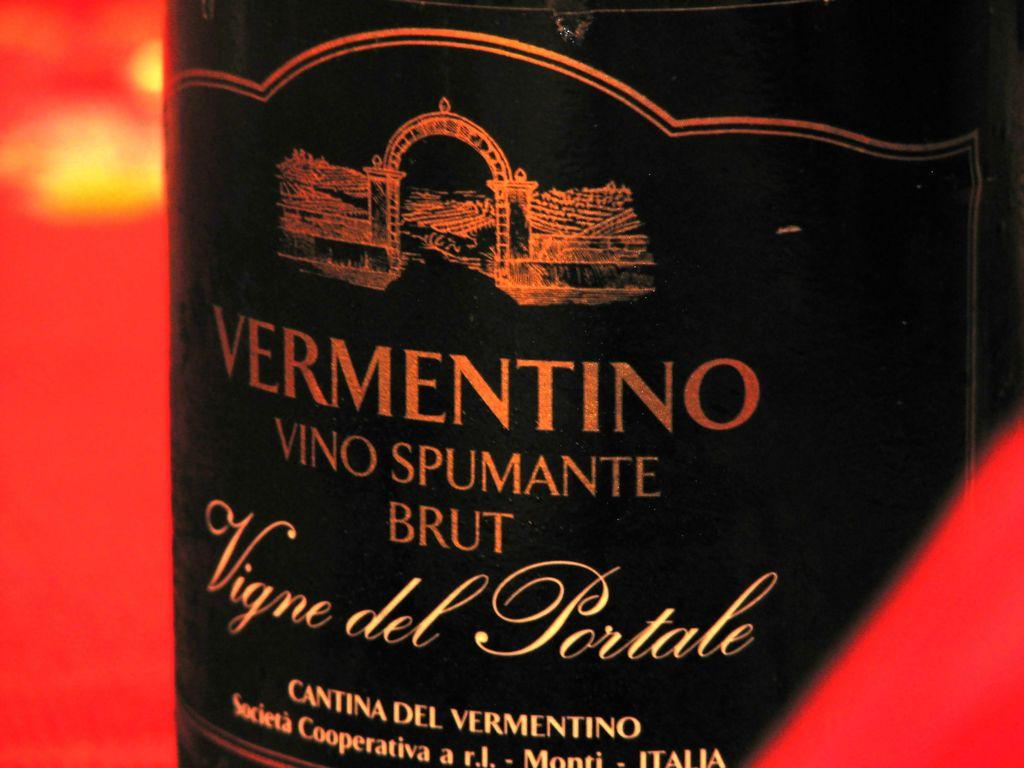<image>
Describe the image concisely. A black label for Vermentino Vigne del Portale. 